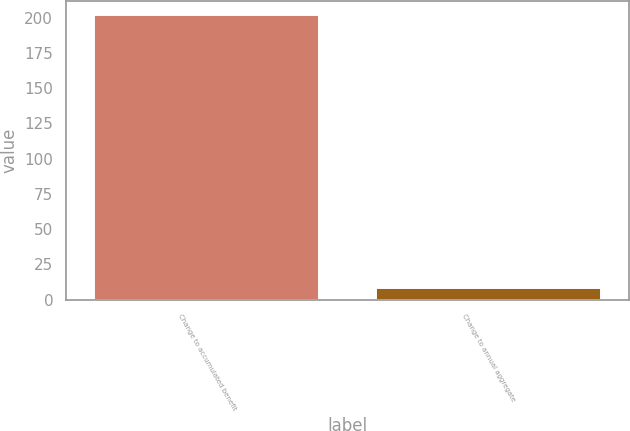Convert chart to OTSL. <chart><loc_0><loc_0><loc_500><loc_500><bar_chart><fcel>Change to accumulated benefit<fcel>Change to annual aggregate<nl><fcel>202<fcel>8<nl></chart> 